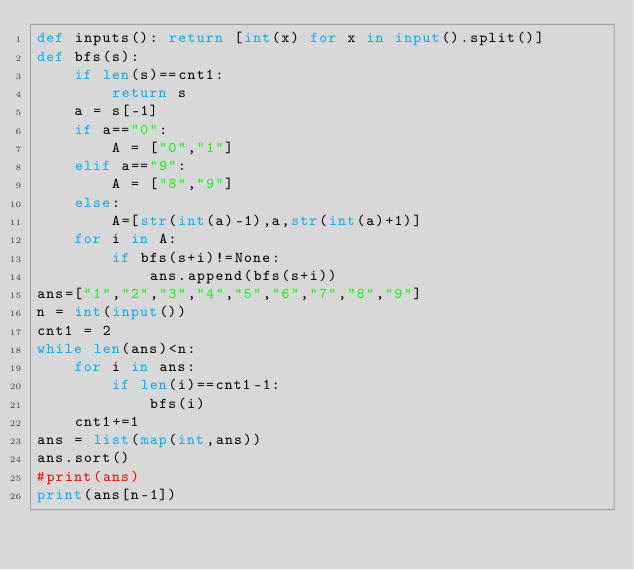Convert code to text. <code><loc_0><loc_0><loc_500><loc_500><_Python_>def inputs(): return [int(x) for x in input().split()]
def bfs(s):
    if len(s)==cnt1:
        return s
    a = s[-1]
    if a=="0":
        A = ["0","1"]
    elif a=="9":
        A = ["8","9"]
    else:
        A=[str(int(a)-1),a,str(int(a)+1)]
    for i in A:
        if bfs(s+i)!=None:
            ans.append(bfs(s+i))
ans=["1","2","3","4","5","6","7","8","9"]
n = int(input())
cnt1 = 2
while len(ans)<n:
    for i in ans:
        if len(i)==cnt1-1:
            bfs(i)
    cnt1+=1
ans = list(map(int,ans))
ans.sort()
#print(ans)
print(ans[n-1])</code> 